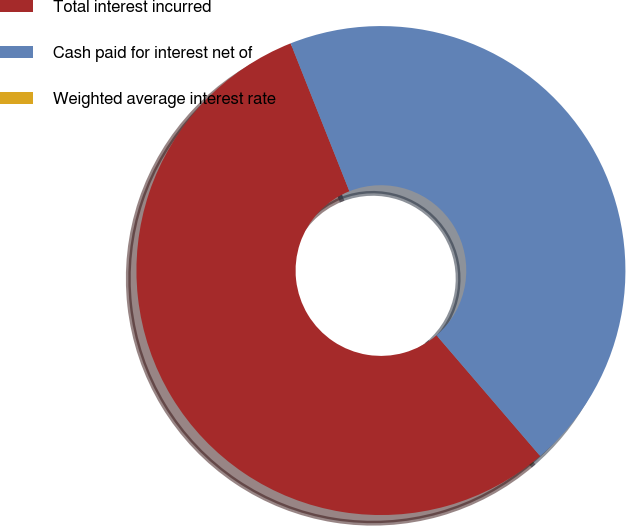<chart> <loc_0><loc_0><loc_500><loc_500><pie_chart><fcel>Total interest incurred<fcel>Cash paid for interest net of<fcel>Weighted average interest rate<nl><fcel>55.27%<fcel>44.73%<fcel>0.0%<nl></chart> 